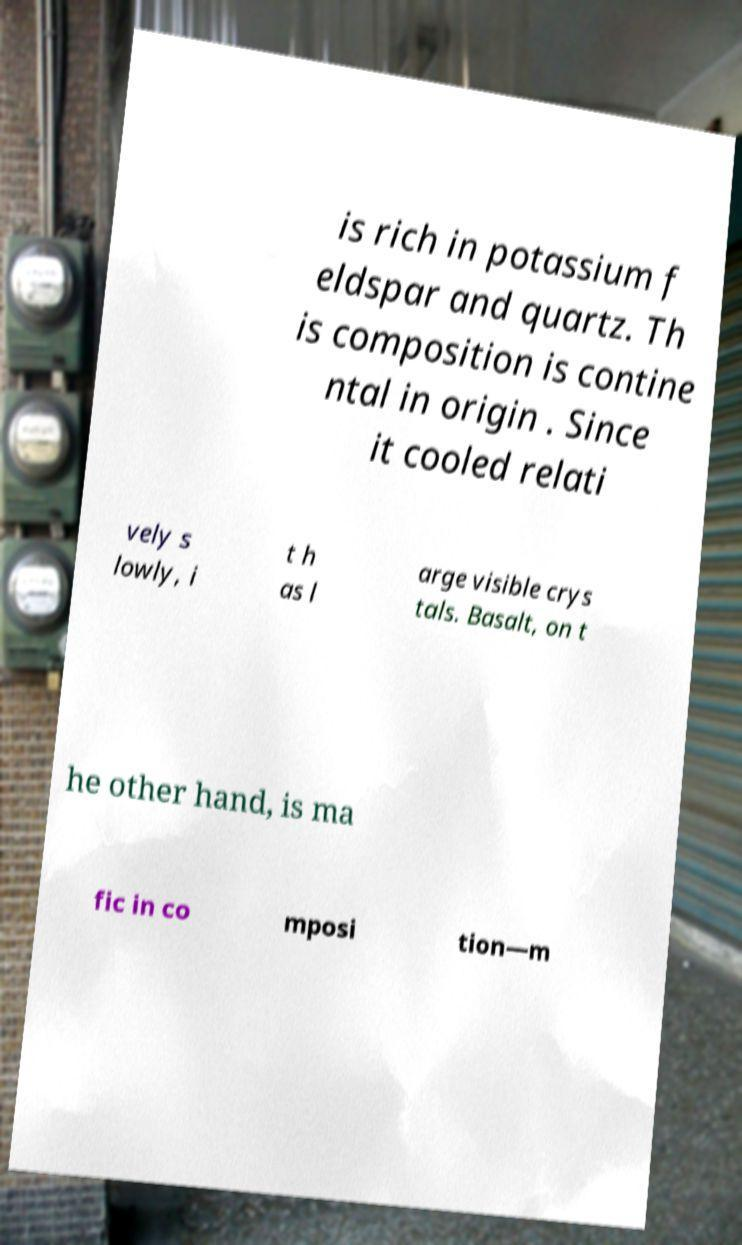For documentation purposes, I need the text within this image transcribed. Could you provide that? is rich in potassium f eldspar and quartz. Th is composition is contine ntal in origin . Since it cooled relati vely s lowly, i t h as l arge visible crys tals. Basalt, on t he other hand, is ma fic in co mposi tion—m 